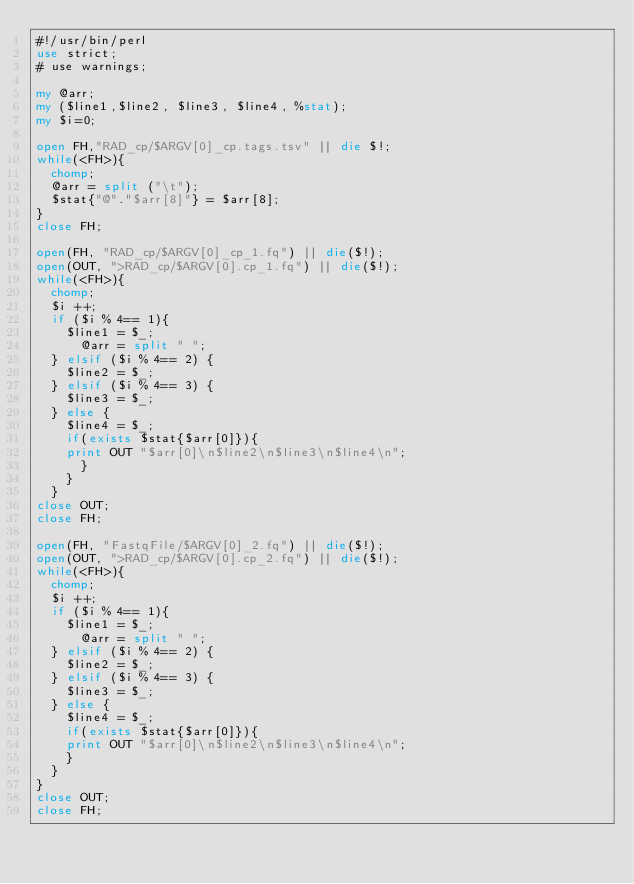Convert code to text. <code><loc_0><loc_0><loc_500><loc_500><_Perl_>#!/usr/bin/perl
use strict;
# use warnings;

my @arr;
my ($line1,$line2, $line3, $line4, %stat);
my $i=0;

open FH,"RAD_cp/$ARGV[0]_cp.tags.tsv" || die $!;
while(<FH>){
	chomp;
	@arr = split ("\t");
	$stat{"@"."$arr[8]"} = $arr[8];
}
close FH;

open(FH, "RAD_cp/$ARGV[0]_cp_1.fq") || die($!);
open(OUT, ">RAD_cp/$ARGV[0].cp_1.fq") || die($!);
while(<FH>){
	chomp;
	$i ++;
	if ($i % 4== 1){
		$line1 = $_;
	    @arr = split " ";
	} elsif ($i % 4== 2) {
		$line2 = $_;
	} elsif ($i % 4== 3) {
		$line3 = $_;
	} else {
		$line4 = $_;
		if(exists $stat{$arr[0]}){
		print OUT "$arr[0]\n$line2\n$line3\n$line4\n";
			}
		}
	}
close OUT;
close FH;

open(FH, "FastqFile/$ARGV[0]_2.fq") || die($!);
open(OUT, ">RAD_cp/$ARGV[0].cp_2.fq") || die($!);
while(<FH>){
	chomp;
	$i ++;
	if ($i % 4== 1){
		$line1 = $_;
	    @arr = split " ";
	} elsif ($i % 4== 2) {
		$line2 = $_;
	} elsif ($i % 4== 3) {
		$line3 = $_;
	} else {
		$line4 = $_;
		if(exists $stat{$arr[0]}){
		print OUT "$arr[0]\n$line2\n$line3\n$line4\n";
		}
	}
}
close OUT;
close FH;
</code> 